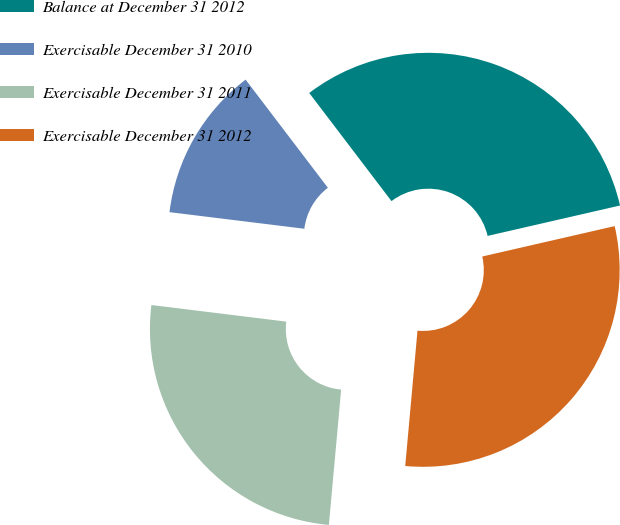Convert chart to OTSL. <chart><loc_0><loc_0><loc_500><loc_500><pie_chart><fcel>Balance at December 31 2012<fcel>Exercisable December 31 2010<fcel>Exercisable December 31 2011<fcel>Exercisable December 31 2012<nl><fcel>31.76%<fcel>12.7%<fcel>25.51%<fcel>30.03%<nl></chart> 